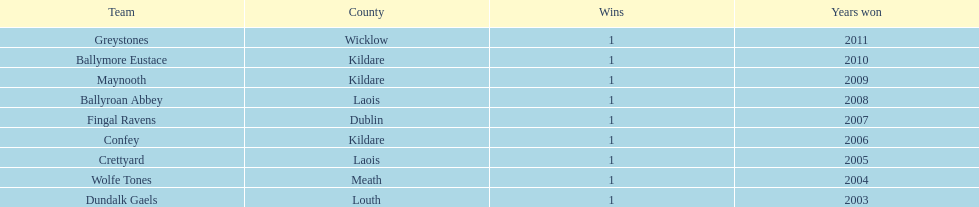What is the overall count of wins on the chart? 9. 